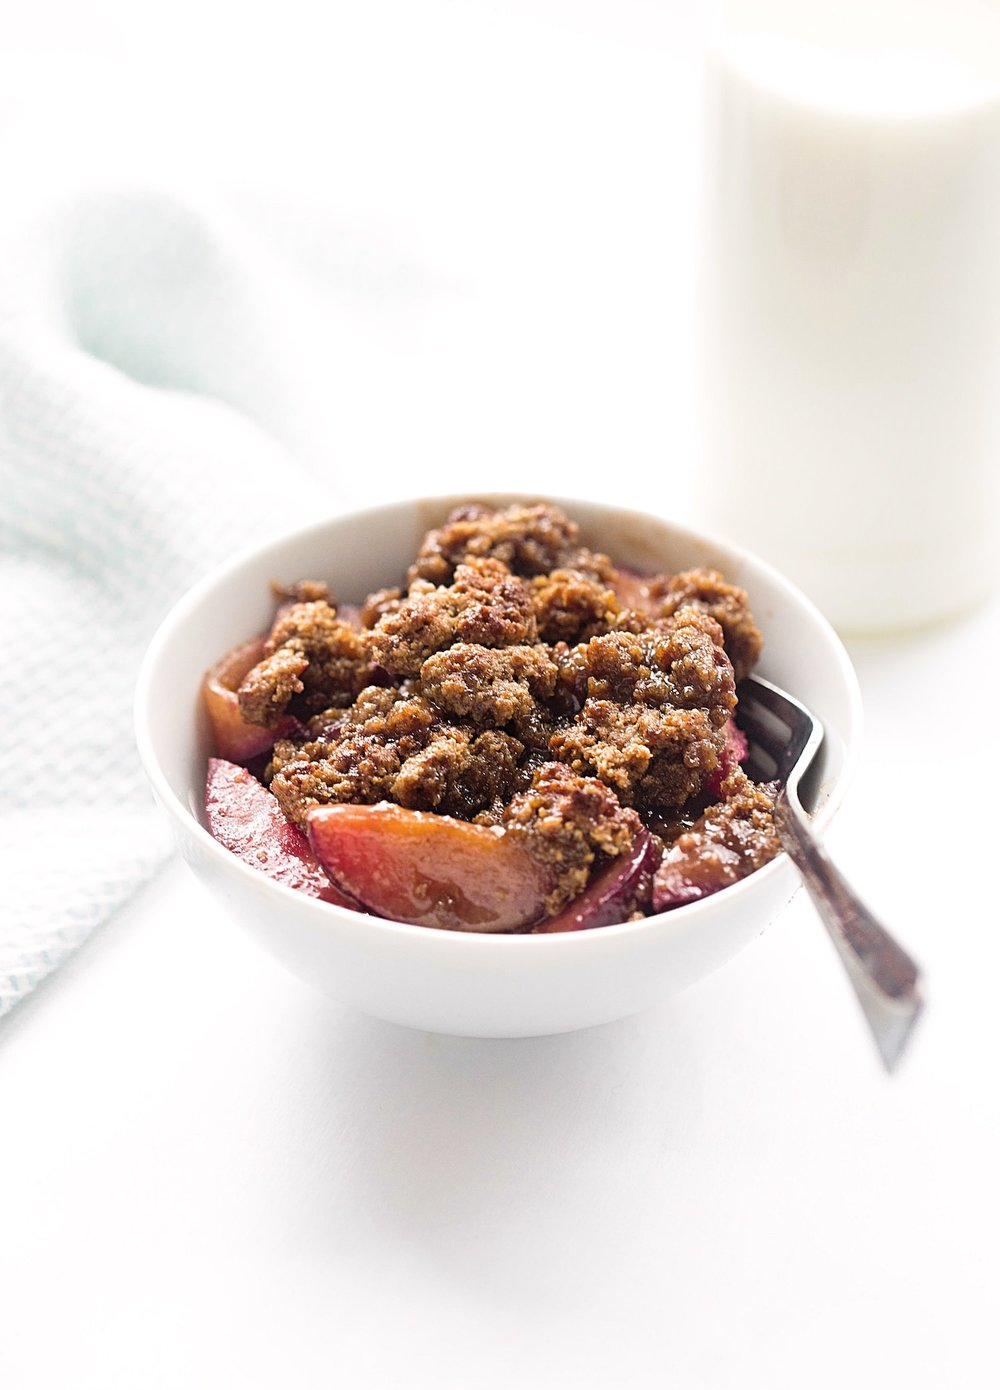What kind of ingredients might be used to make this crumble topping? The crumble topping likely includes a mixture of flour, butter, and sugar, often combined with oats for texture and nuts for added crunch. It may also include spices such as cinnamon or nutmeg to complement the fruit filling. 